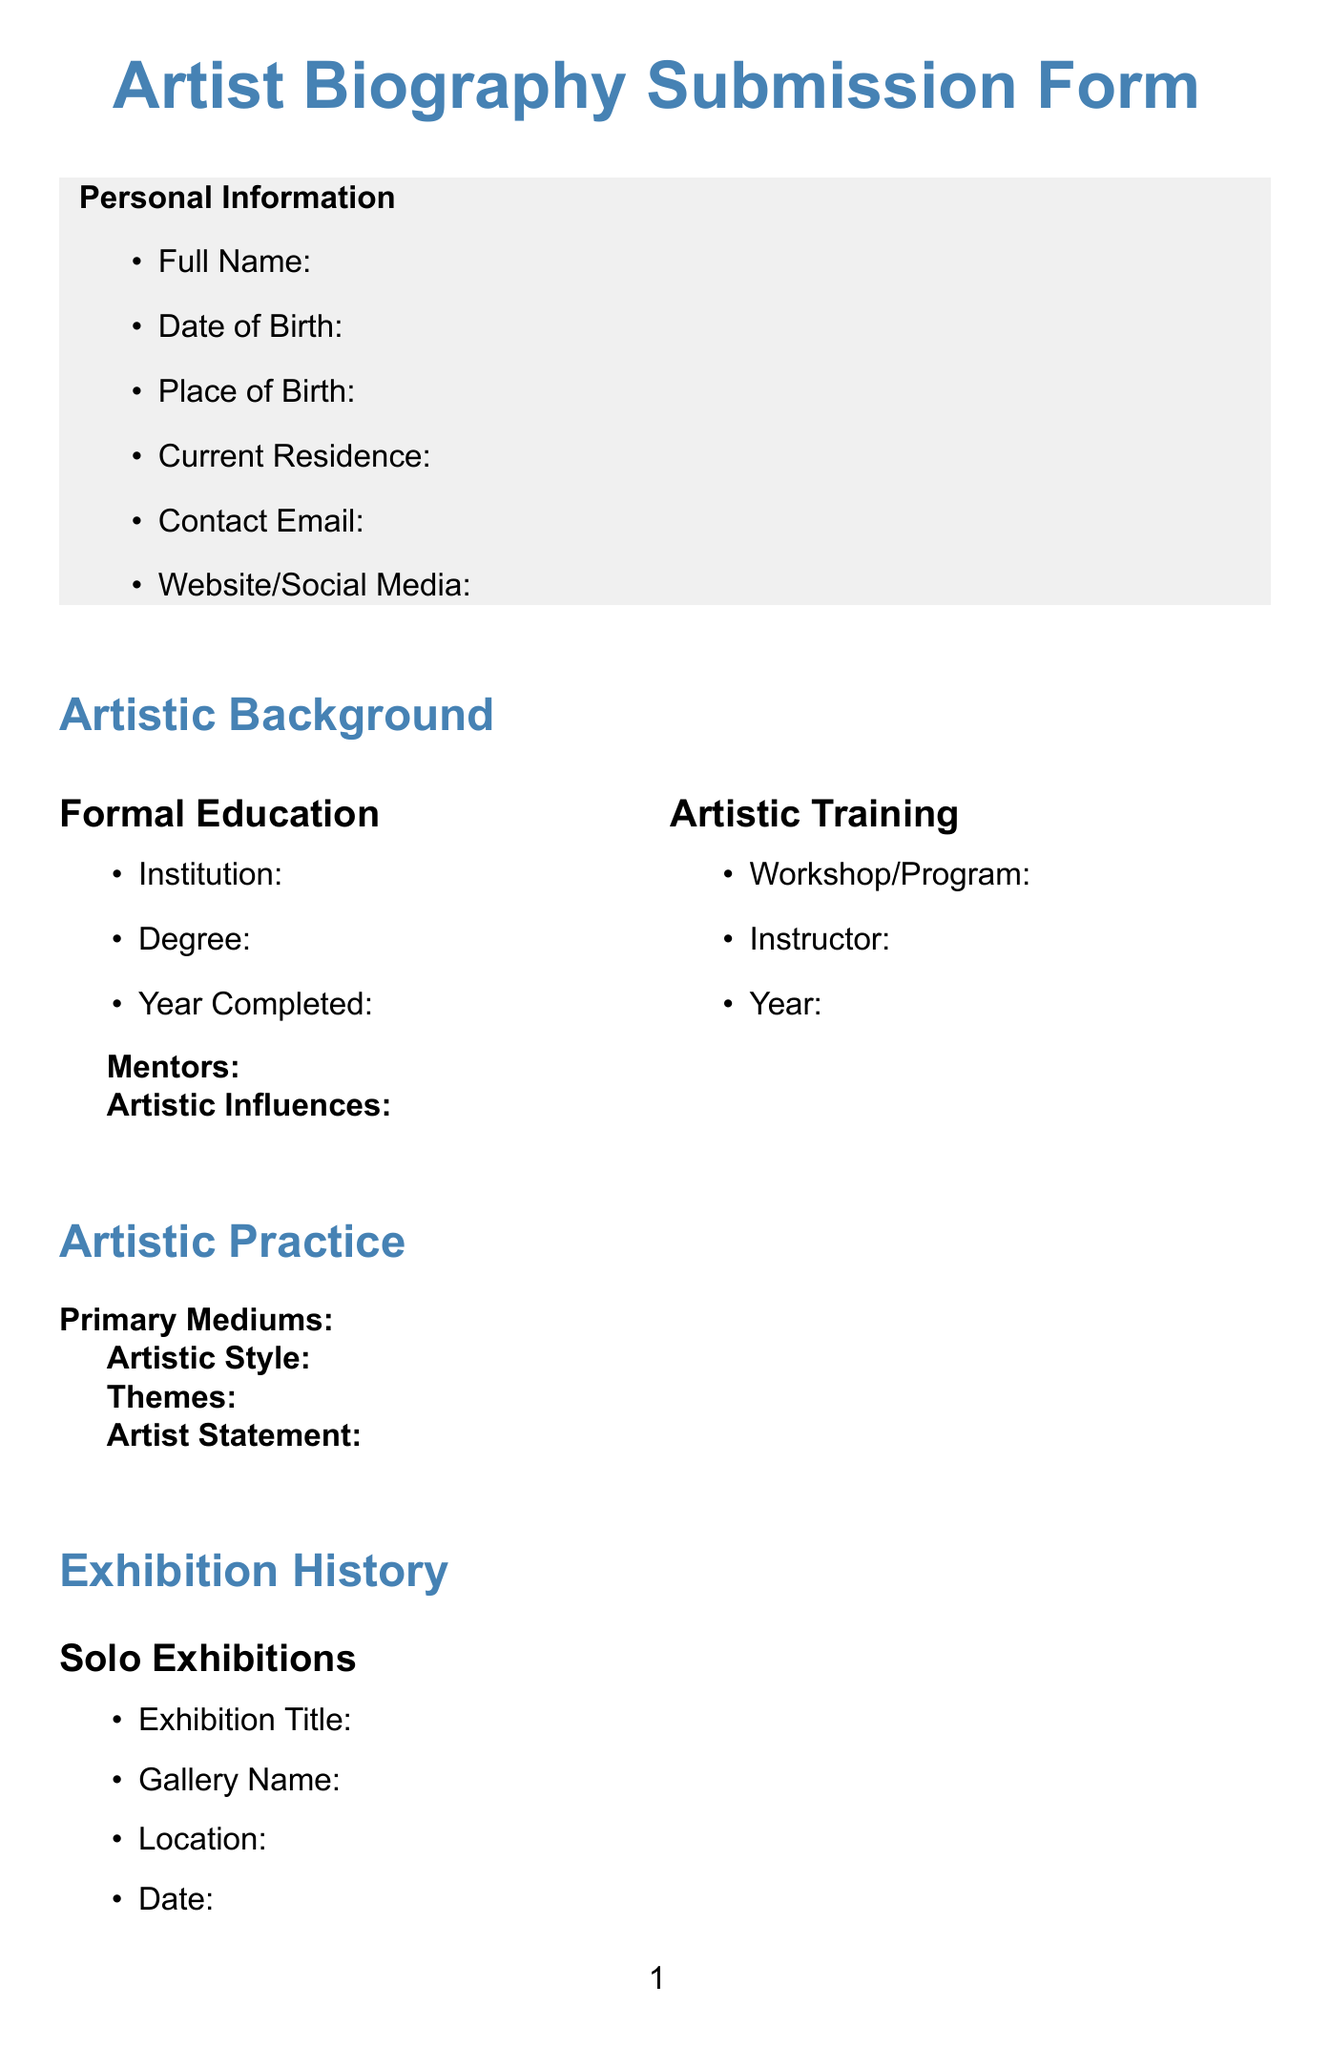what is the title of the form? The title of the form is specified at the top of the document as the Artist Biography Submission Form.
Answer: Artist Biography Submission Form 